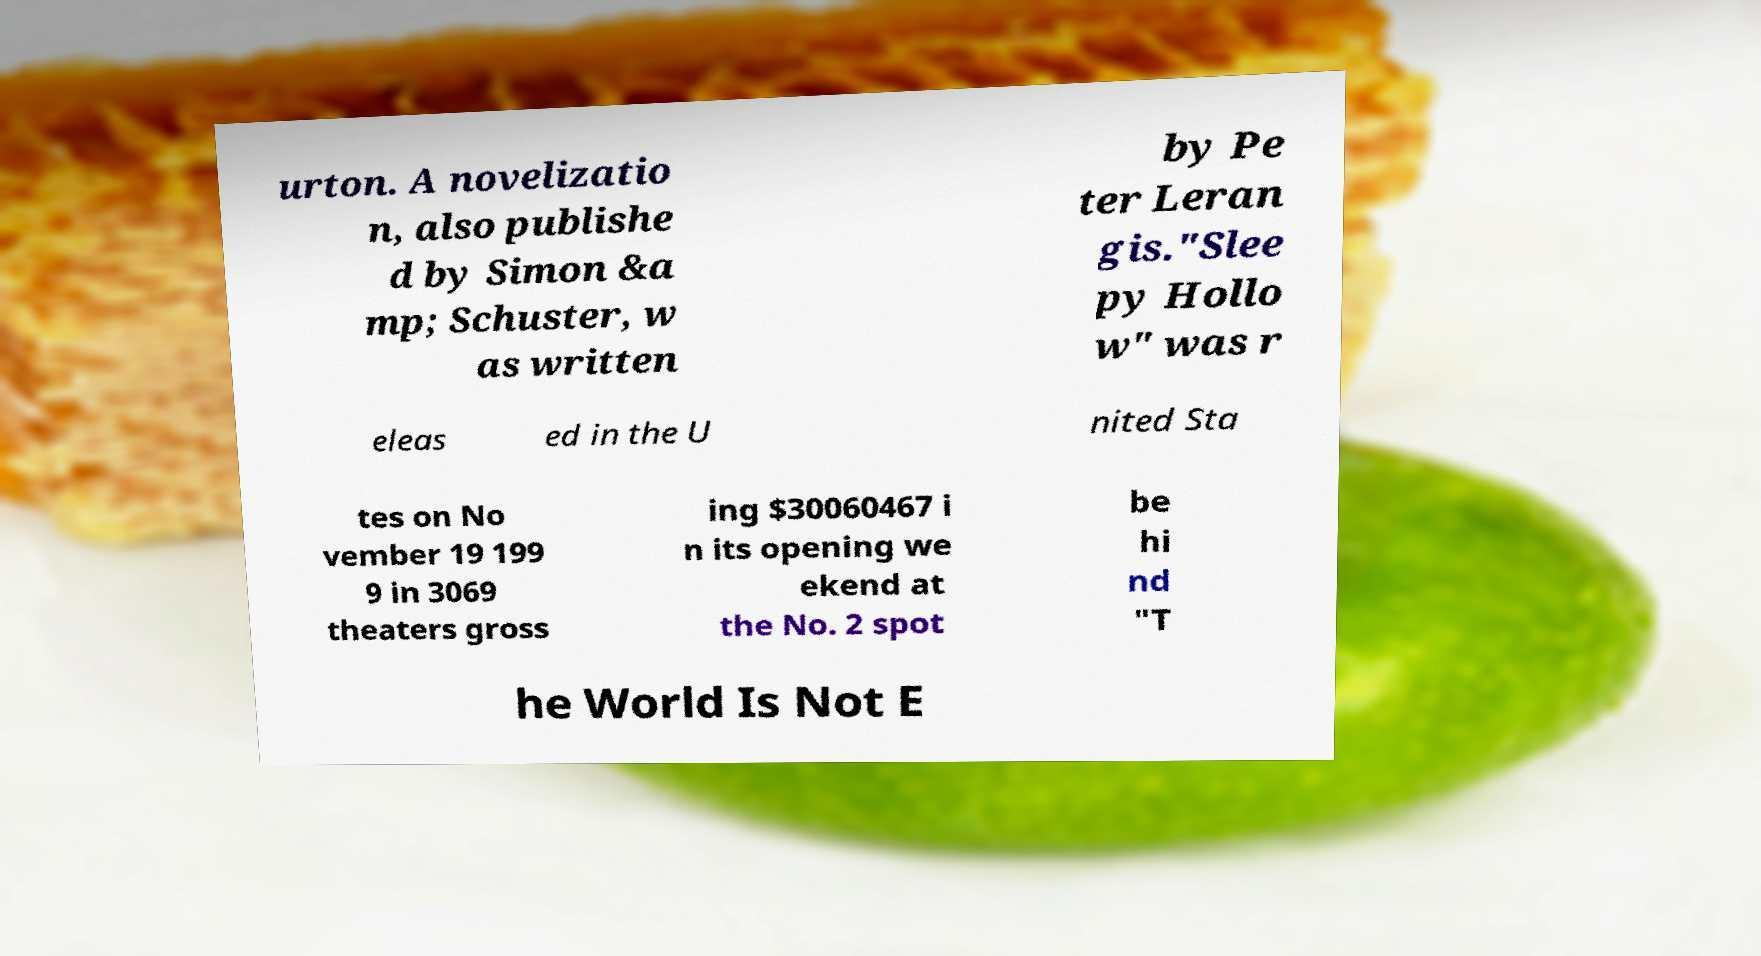For documentation purposes, I need the text within this image transcribed. Could you provide that? urton. A novelizatio n, also publishe d by Simon &a mp; Schuster, w as written by Pe ter Leran gis."Slee py Hollo w" was r eleas ed in the U nited Sta tes on No vember 19 199 9 in 3069 theaters gross ing $30060467 i n its opening we ekend at the No. 2 spot be hi nd "T he World Is Not E 